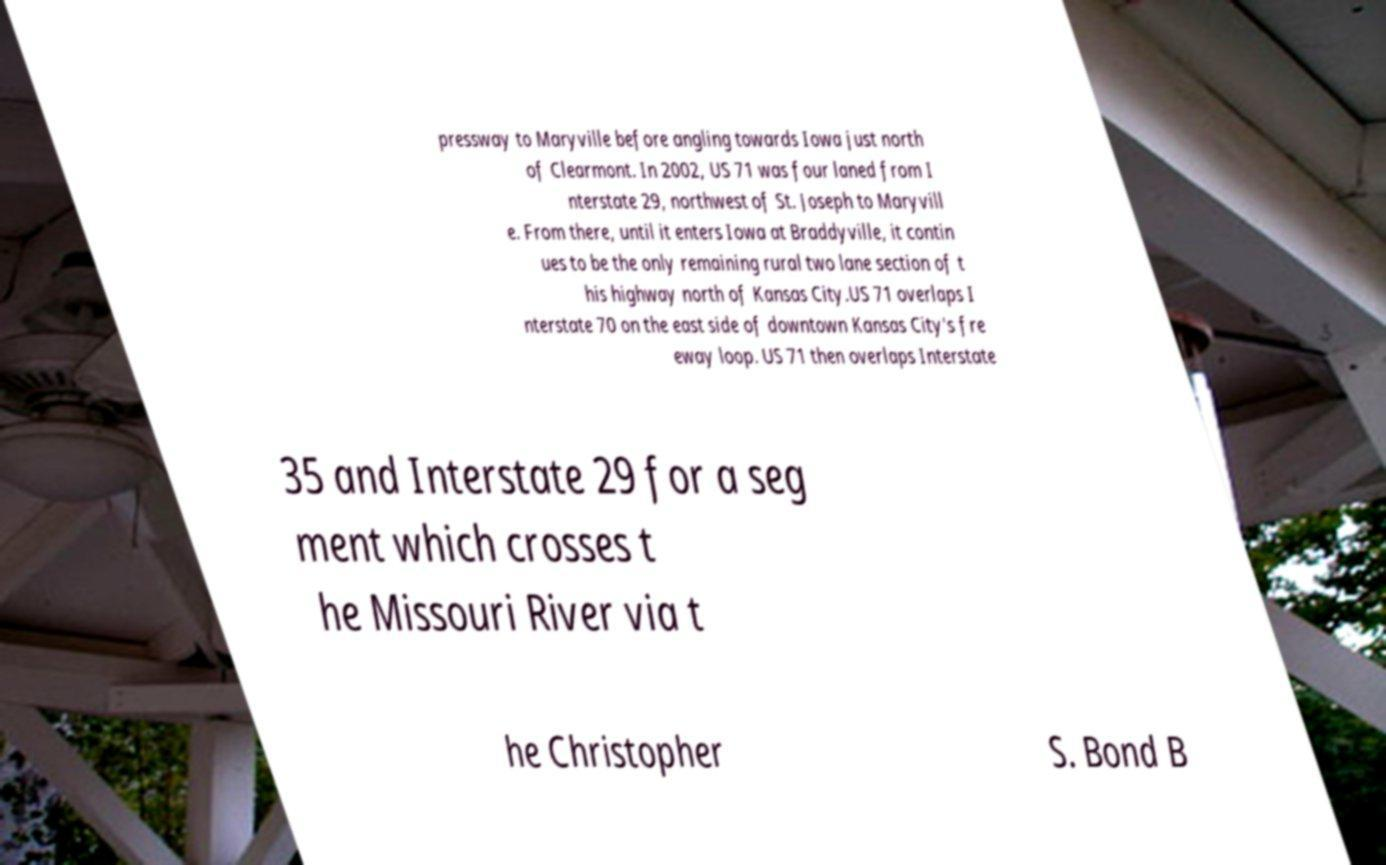There's text embedded in this image that I need extracted. Can you transcribe it verbatim? pressway to Maryville before angling towards Iowa just north of Clearmont. In 2002, US 71 was four laned from I nterstate 29, northwest of St. Joseph to Maryvill e. From there, until it enters Iowa at Braddyville, it contin ues to be the only remaining rural two lane section of t his highway north of Kansas City.US 71 overlaps I nterstate 70 on the east side of downtown Kansas City's fre eway loop. US 71 then overlaps Interstate 35 and Interstate 29 for a seg ment which crosses t he Missouri River via t he Christopher S. Bond B 